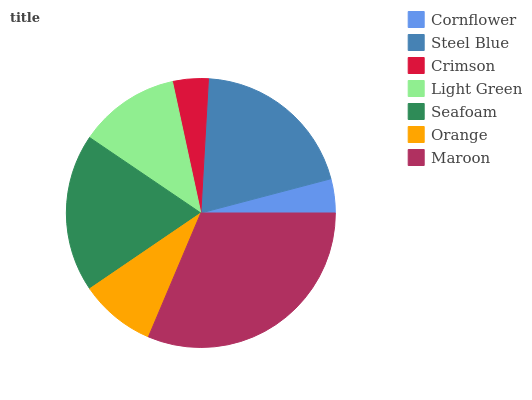Is Cornflower the minimum?
Answer yes or no. Yes. Is Maroon the maximum?
Answer yes or no. Yes. Is Steel Blue the minimum?
Answer yes or no. No. Is Steel Blue the maximum?
Answer yes or no. No. Is Steel Blue greater than Cornflower?
Answer yes or no. Yes. Is Cornflower less than Steel Blue?
Answer yes or no. Yes. Is Cornflower greater than Steel Blue?
Answer yes or no. No. Is Steel Blue less than Cornflower?
Answer yes or no. No. Is Light Green the high median?
Answer yes or no. Yes. Is Light Green the low median?
Answer yes or no. Yes. Is Seafoam the high median?
Answer yes or no. No. Is Steel Blue the low median?
Answer yes or no. No. 